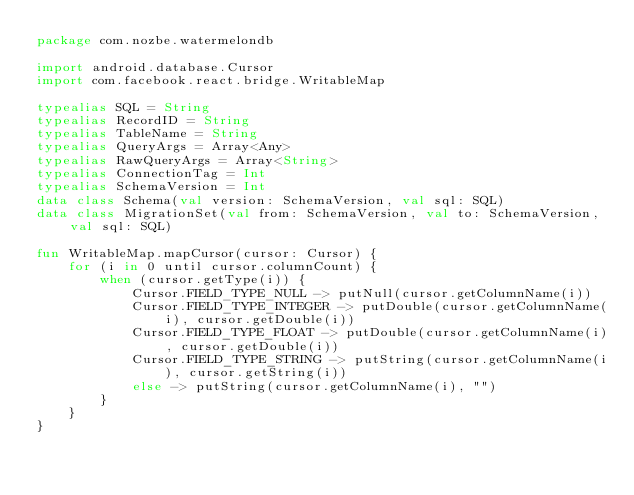Convert code to text. <code><loc_0><loc_0><loc_500><loc_500><_Kotlin_>package com.nozbe.watermelondb

import android.database.Cursor
import com.facebook.react.bridge.WritableMap

typealias SQL = String
typealias RecordID = String
typealias TableName = String
typealias QueryArgs = Array<Any>
typealias RawQueryArgs = Array<String>
typealias ConnectionTag = Int
typealias SchemaVersion = Int
data class Schema(val version: SchemaVersion, val sql: SQL)
data class MigrationSet(val from: SchemaVersion, val to: SchemaVersion, val sql: SQL)

fun WritableMap.mapCursor(cursor: Cursor) {
    for (i in 0 until cursor.columnCount) {
        when (cursor.getType(i)) {
            Cursor.FIELD_TYPE_NULL -> putNull(cursor.getColumnName(i))
            Cursor.FIELD_TYPE_INTEGER -> putDouble(cursor.getColumnName(i), cursor.getDouble(i))
            Cursor.FIELD_TYPE_FLOAT -> putDouble(cursor.getColumnName(i), cursor.getDouble(i))
            Cursor.FIELD_TYPE_STRING -> putString(cursor.getColumnName(i), cursor.getString(i))
            else -> putString(cursor.getColumnName(i), "")
        }
    }
}
</code> 